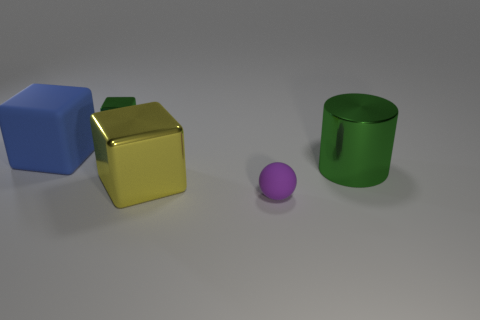How might the objects in the image be used in a practical scenario? These objects could serve as educational tools for a variety of learning activities. The blue and yellow cubes could help teach concepts of geometry and mathematics, such as understanding three-dimensional shapes and volume. The purple sphere might be used in lessons about round objects and concepts of rolling and friction. Lastly, the green cylinder could be a container for holding items or an example in teaching about cylinders and storage. The bright colors might further engage young learners' attention and curiosity. 